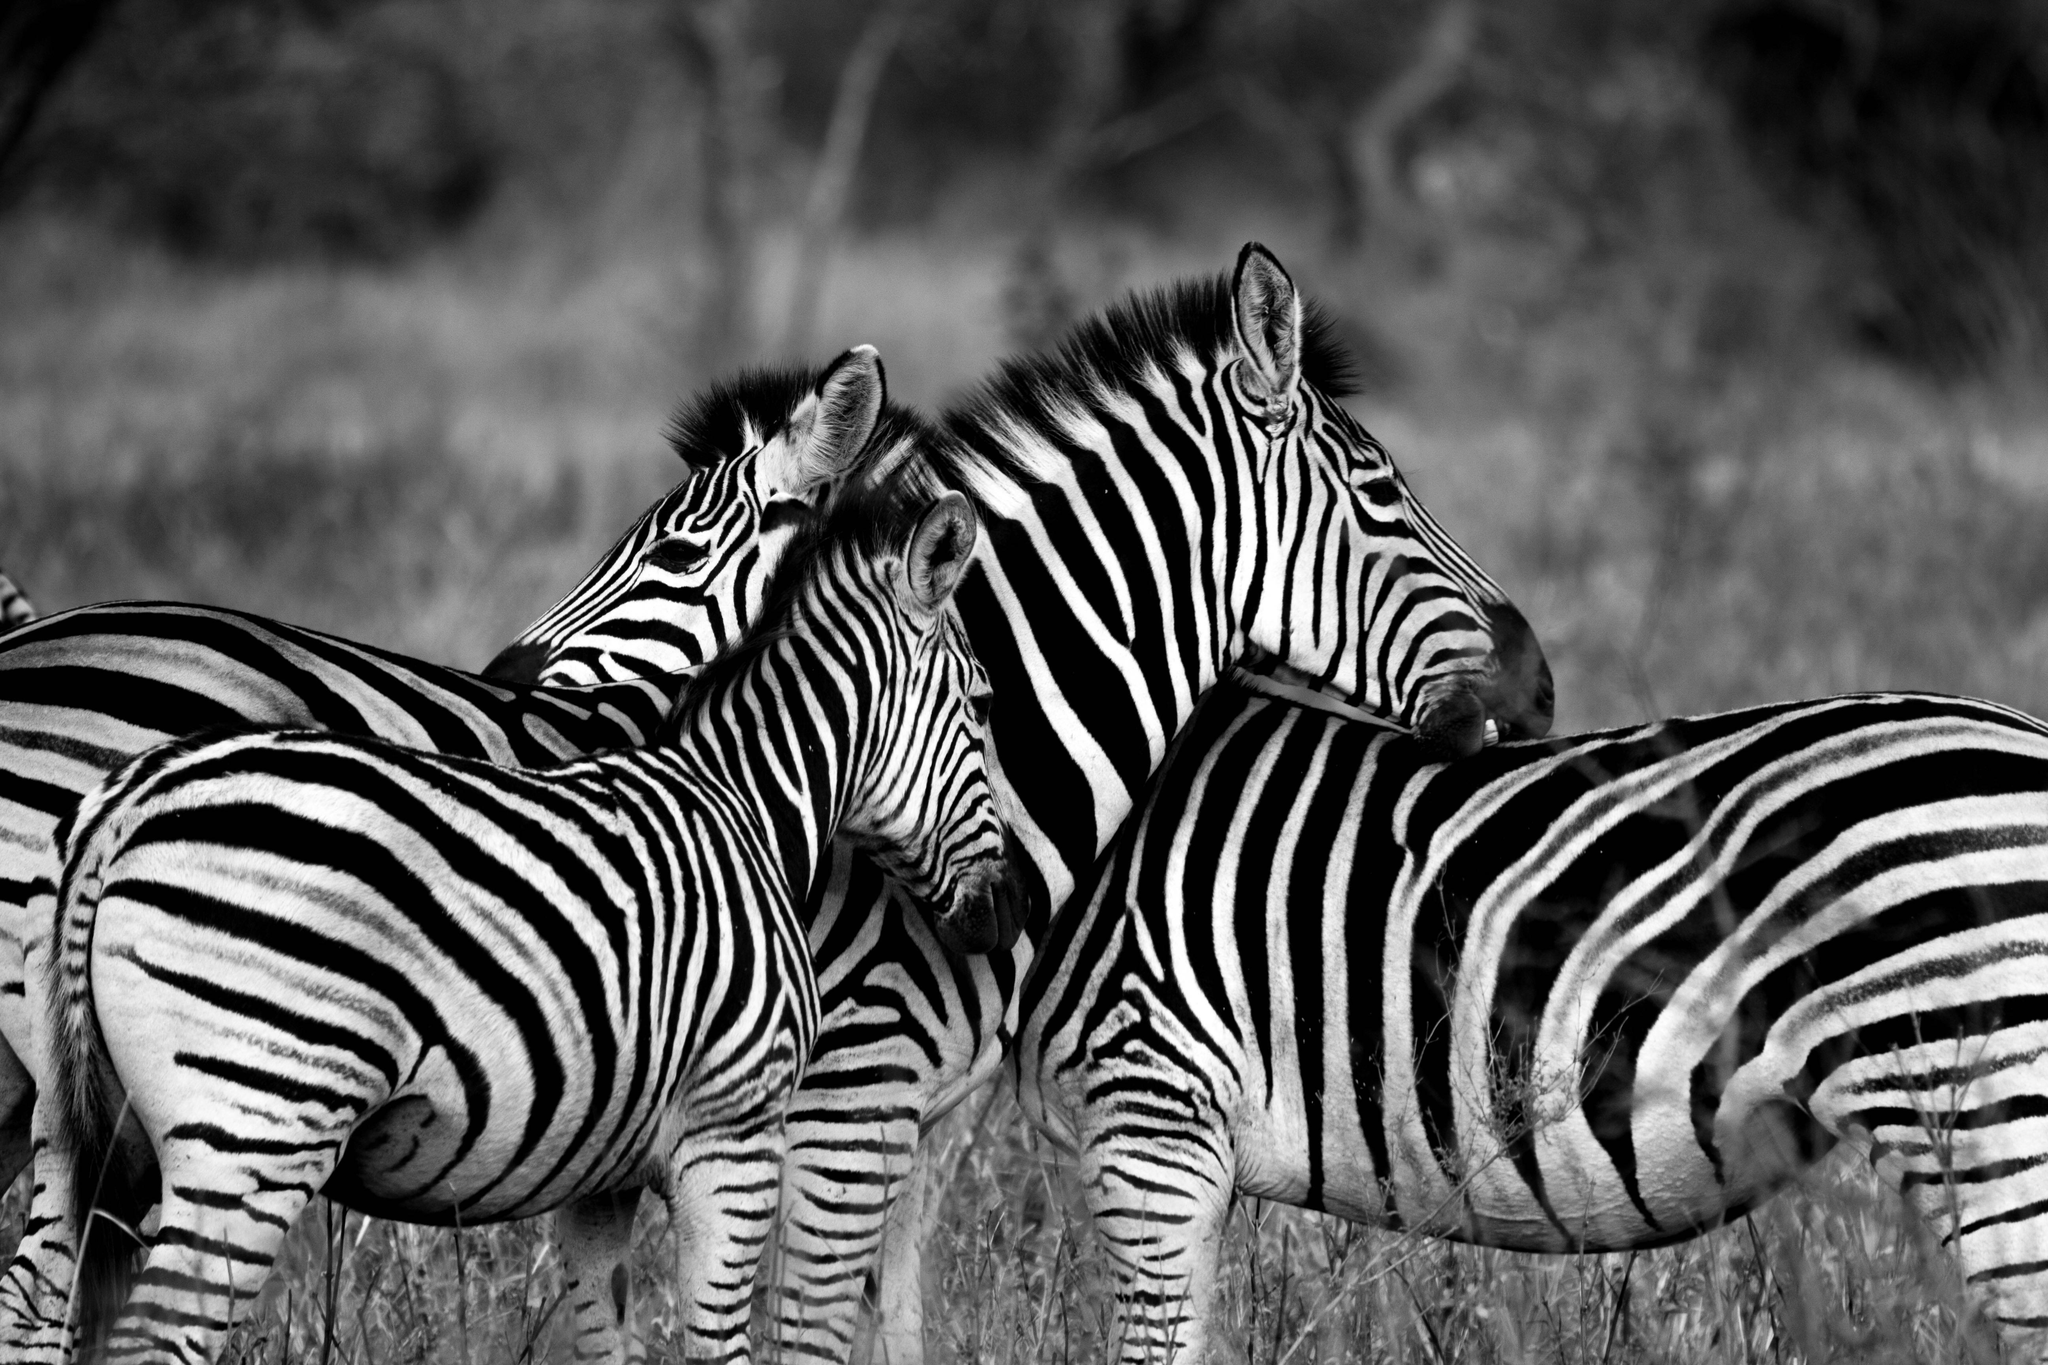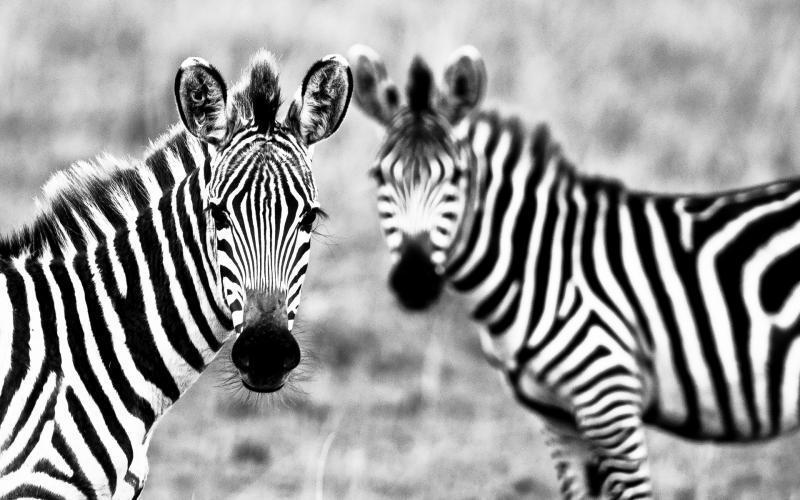The first image is the image on the left, the second image is the image on the right. Considering the images on both sides, is "Both images have the same number of zebras." valid? Answer yes or no. No. The first image is the image on the left, the second image is the image on the right. Assess this claim about the two images: "Two standing zebras whose heads are parallel in height have their bodies turned toward each other in the right image.". Correct or not? Answer yes or no. Yes. 